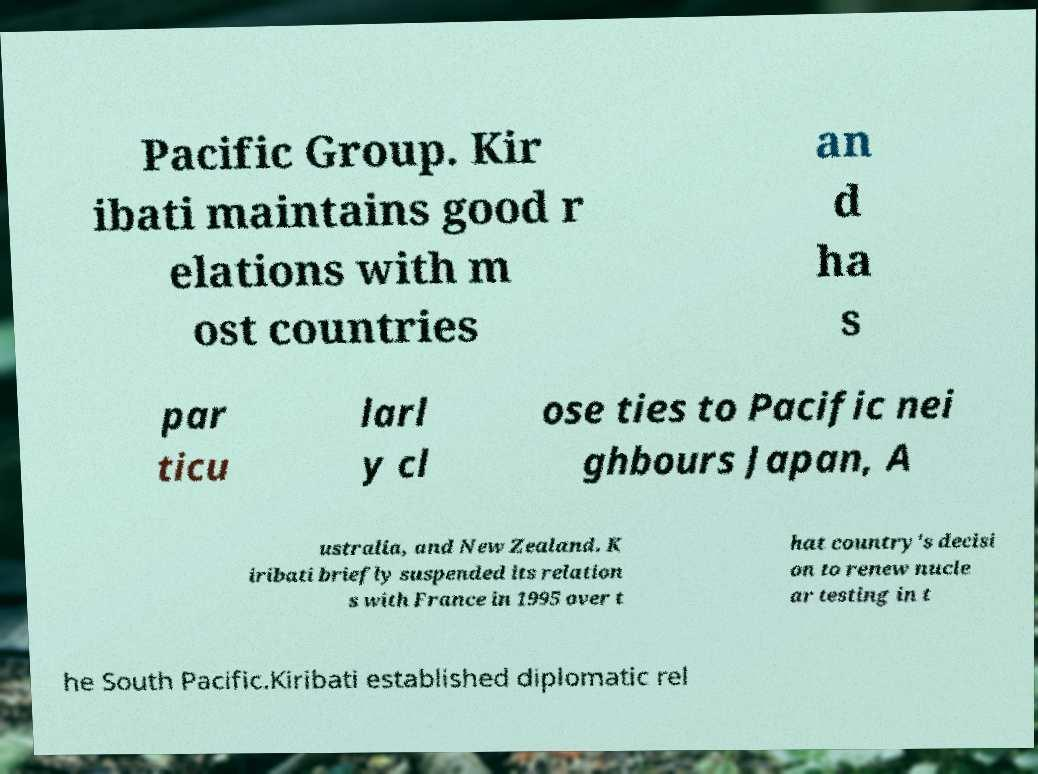Could you extract and type out the text from this image? Pacific Group. Kir ibati maintains good r elations with m ost countries an d ha s par ticu larl y cl ose ties to Pacific nei ghbours Japan, A ustralia, and New Zealand. K iribati briefly suspended its relation s with France in 1995 over t hat country's decisi on to renew nucle ar testing in t he South Pacific.Kiribati established diplomatic rel 